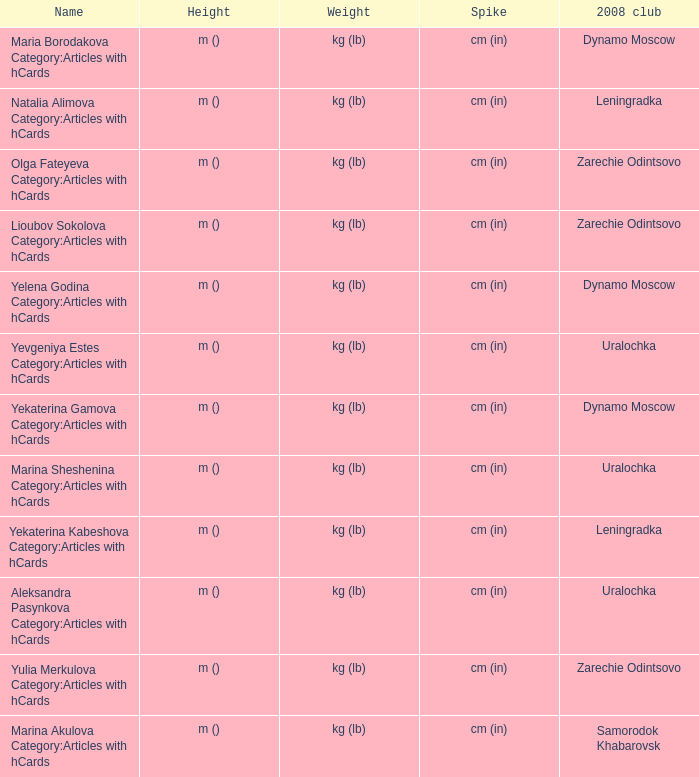What is the name when the 2008 club is uralochka? Yevgeniya Estes Category:Articles with hCards, Marina Sheshenina Category:Articles with hCards, Aleksandra Pasynkova Category:Articles with hCards. 